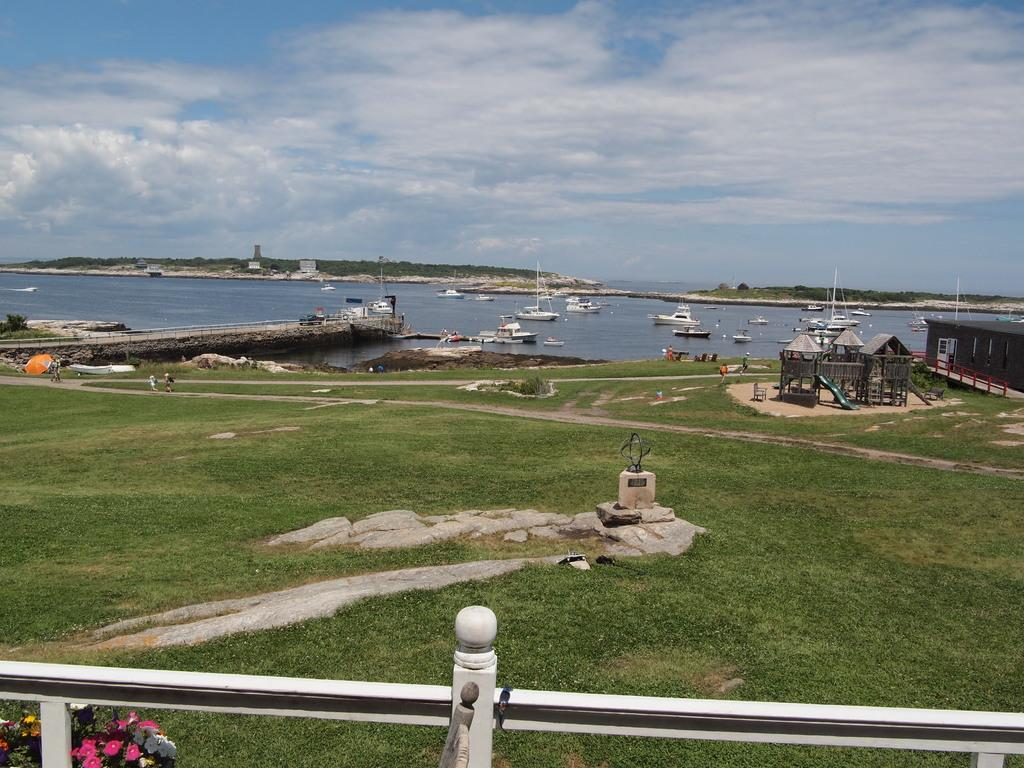What type of vegetation is present in the image? There is grass in the image. What is located behind the grass? There is a water surface behind the grass. What can be seen on the water surface? There are ships on the water. What structure is on the right side of the image? There is a wooden construction on the right side of the image. Can you tell me how many berries are growing on the wooden construction in the image? There are no berries present in the image, and the wooden construction does not have any plants growing on it. How does the tramp contribute to the profit of the ships in the image? There is no tramp or mention of profit in the image; it features grass, a water surface, ships, and a wooden construction. 